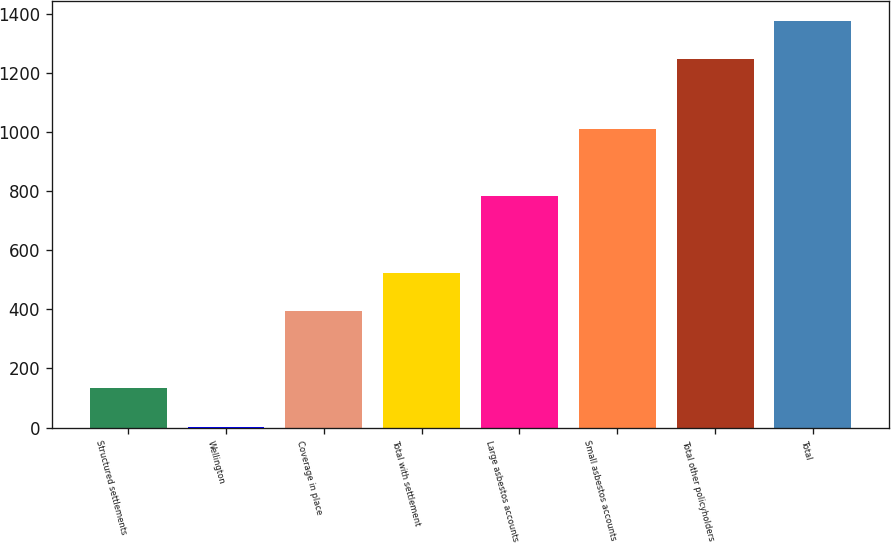Convert chart to OTSL. <chart><loc_0><loc_0><loc_500><loc_500><bar_chart><fcel>Structured settlements<fcel>Wellington<fcel>Coverage in place<fcel>Total with settlement<fcel>Large asbestos accounts<fcel>Small asbestos accounts<fcel>Total other policyholders<fcel>Total<nl><fcel>132.9<fcel>3<fcel>392.7<fcel>522.6<fcel>782.4<fcel>1009<fcel>1245<fcel>1374.9<nl></chart> 